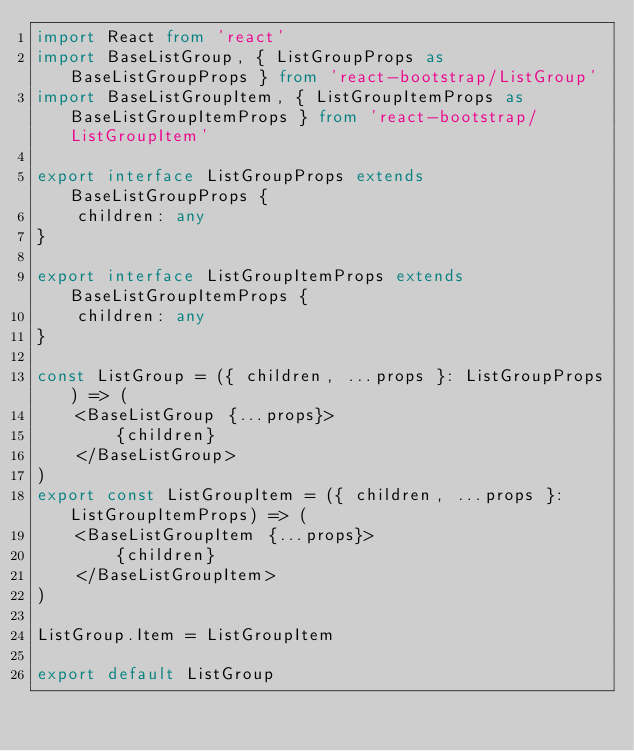Convert code to text. <code><loc_0><loc_0><loc_500><loc_500><_TypeScript_>import React from 'react'
import BaseListGroup, { ListGroupProps as BaseListGroupProps } from 'react-bootstrap/ListGroup'
import BaseListGroupItem, { ListGroupItemProps as BaseListGroupItemProps } from 'react-bootstrap/ListGroupItem'

export interface ListGroupProps extends BaseListGroupProps {
    children: any
}

export interface ListGroupItemProps extends BaseListGroupItemProps {
    children: any
}

const ListGroup = ({ children, ...props }: ListGroupProps) => (
    <BaseListGroup {...props}>
        {children}
    </BaseListGroup>
)
export const ListGroupItem = ({ children, ...props }: ListGroupItemProps) => (
    <BaseListGroupItem {...props}>
        {children}
    </BaseListGroupItem>
)

ListGroup.Item = ListGroupItem

export default ListGroup
</code> 